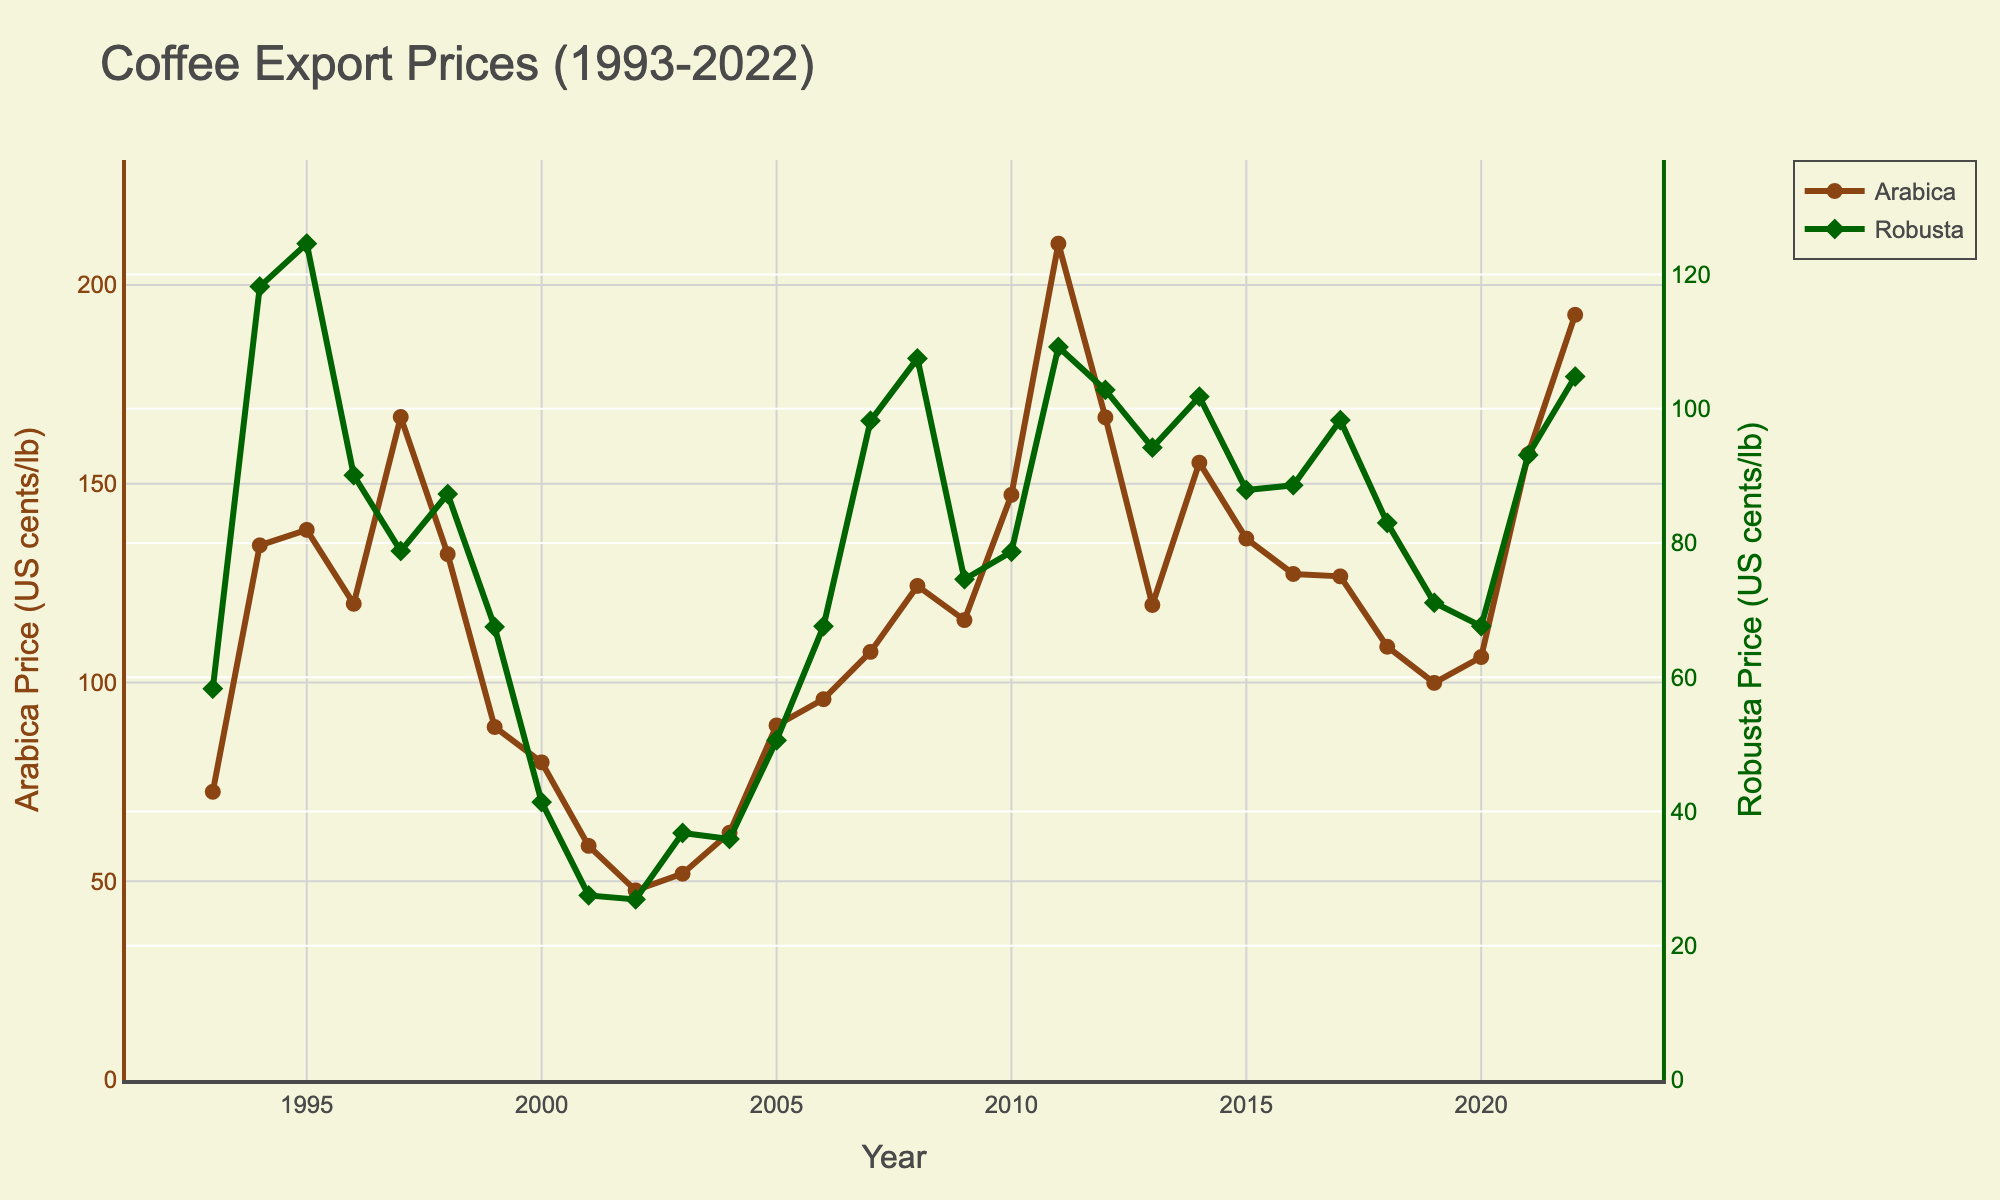What was the maximum price of Arabica coffee over the years? Look for the peak point on the Arabica line chart. The highest value is around 210.4 US cents/lb in 2011.
Answer: 210.4 US cents/lb How did the price of Robusta coffee in 2022 compare to its price in 1993? Check the Robusta price for 2022 and 1993 on the line chart. In 1993 it was 58.3, and in 2022 it was 104.8. Since 104.8 > 58.3, the price increased.
Answer: Increased Which year had the lowest price for Arabica coffee? Locate the lowest data point for Arabica on the chart. The lowest value is around 47.7 US cents/lb in 2002.
Answer: 2002 What's the average price of Robusta coffee from 2018 to 2022? Select the Robusta prices for 2018, 2019, 2020, 2021, and 2022 (83.0, 71.1, 67.6, 93.1, 104.8). Sum the values and divide by the number of years: (83.0 + 71.1 + 67.6 + 93.1 + 104.8) / 5 = 83.92.
Answer: 83.92 US cents/lb In which year did Arabica coffee see its sharpest price drop? Identify the years with the largest decline from one year to the next on the Arabica line chart. Between 2011 and 2012, it dropped from 210.4 to 166.7, a difference of 43.7 US cents/lb.
Answer: 2011-2012 Which coffee variety had the higher price in 2007? Compare the prices of Arabica (107.7) and Robusta (98.2) in 2007. Since 107.7 > 98.2, Arabica was higher.
Answer: Arabica By how much did the price of Robusta coffee increase from 2001 to 2008? Subtract the 2001 price from the 2008 price for Robusta. 107.5 - 27.5 = 80.0 US cents/lb.
Answer: 80.0 US cents/lb What is the visual marker used for Arabica coffee in the chart? Look at the symbols on the Arabica line; they are circles.
Answer: Circle Describe the trend in Arabica coffee prices from 1993 to 2022. Observe the general direction of the Arabica line. It fluctuates but shows a rising trend overall, reaching a peak in 2011, followed by intermittent increases and decreases.
Answer: Fluctuating upward trend Which year marks the closest price parity between Arabica and Robusta? Find the year where the difference between Arabica and Robusta prices is smallest. In 1994, Arabica is 134.5, and Robusta is 118.2, with a difference of 16.3 US cents/lb, which is the smallest observed.
Answer: 1994 